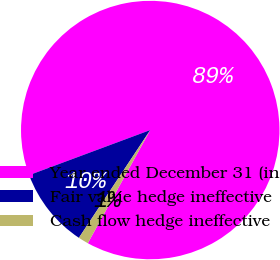<chart> <loc_0><loc_0><loc_500><loc_500><pie_chart><fcel>Year ended December 31 (in<fcel>Fair value hedge ineffective<fcel>Cash flow hedge ineffective<nl><fcel>88.7%<fcel>10.02%<fcel>1.28%<nl></chart> 